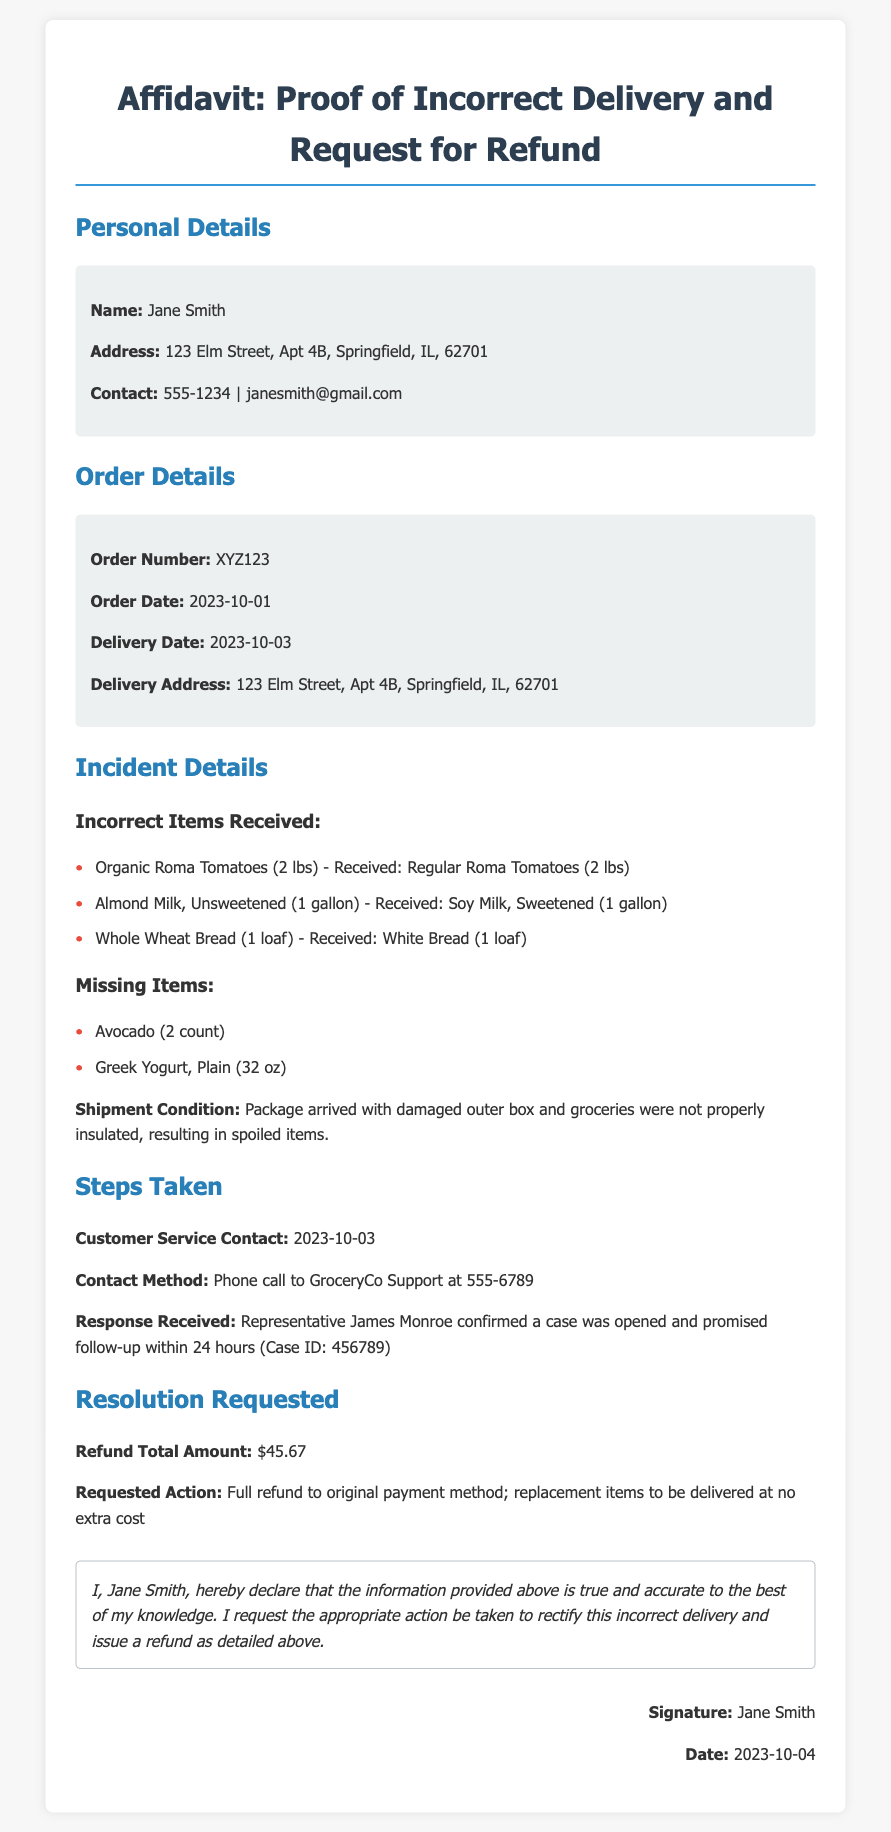What is the name of the person who signed the affidavit? The name of the person is provided in the Personal Details section of the document.
Answer: Jane Smith What is the order number? The order number is listed under Order Details in the document.
Answer: XYZ123 What was the delivery date? The delivery date is specified in the Order Details section of the document.
Answer: 2023-10-03 What is the refund total amount requested? The total amount requested for the refund is found in the Resolution Requested section.
Answer: $45.67 How many incorrect items were received? The number of incorrect items received can be counted from the list provided under Incident Details.
Answer: 3 Which customer service representative was contacted? The representative's name is mentioned in the Steps Taken section of the document.
Answer: James Monroe What was the condition of the shipment upon arrival? The condition of the shipment is described in the Incident Details section.
Answer: Damaged outer box What method was used to contact customer service? The method of contact is specified in the Steps Taken section of the document.
Answer: Phone call What is the address provided for the delivery? The delivery address is stated in the Order Details section of the document.
Answer: 123 Elm Street, Apt 4B, Springfield, IL, 62701 